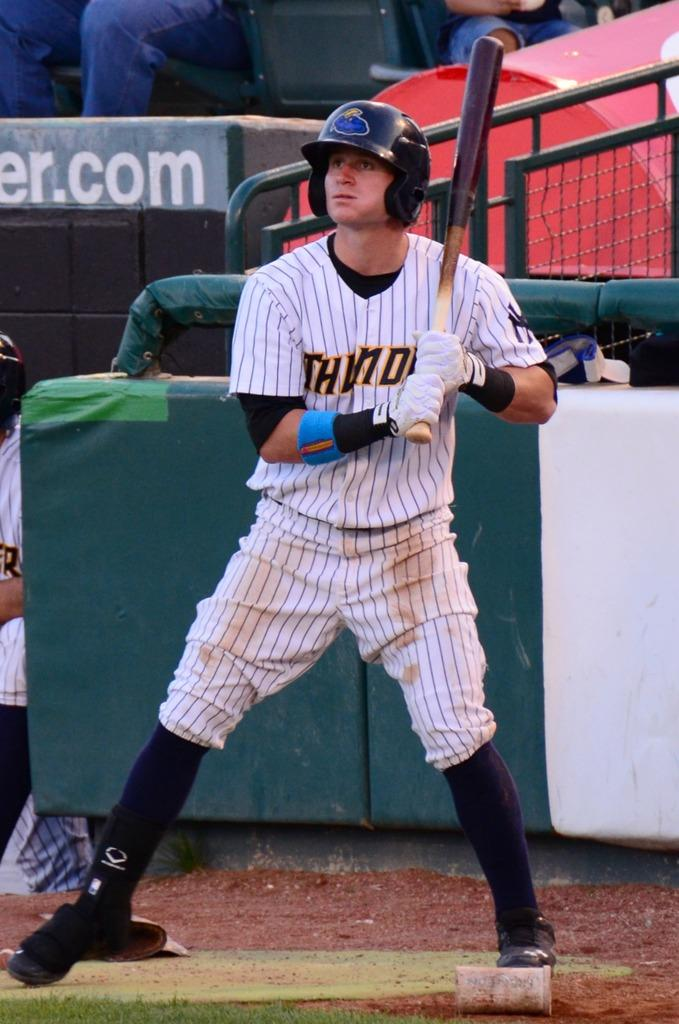<image>
Create a compact narrative representing the image presented. A baseball player whose jersey says, 'Thunder', is about to swing his bat in front of a .com sign. 